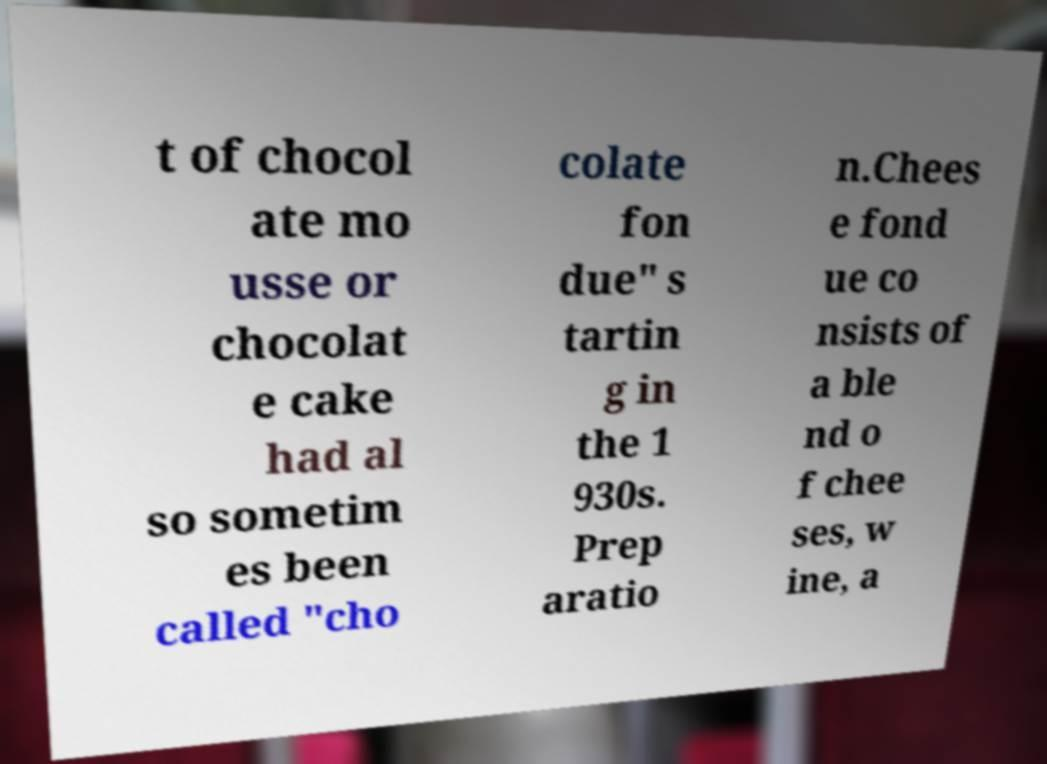Please identify and transcribe the text found in this image. t of chocol ate mo usse or chocolat e cake had al so sometim es been called "cho colate fon due" s tartin g in the 1 930s. Prep aratio n.Chees e fond ue co nsists of a ble nd o f chee ses, w ine, a 